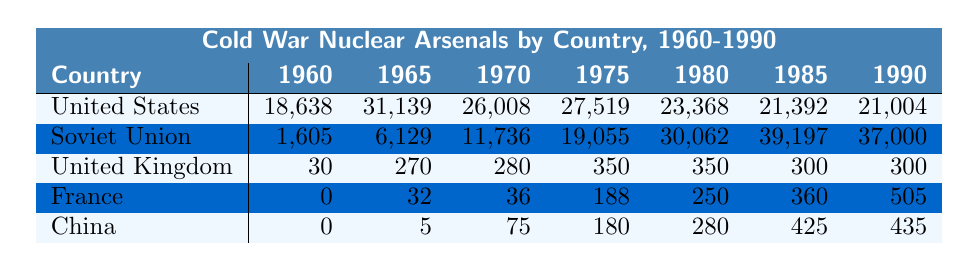What was the status of China's nuclear arsenal in 1960? According to the table, China had no nuclear weapons in 1960, as indicated by the value of 0.
Answer: 0 Which country had the highest number of nuclear warheads in 1985? In the year 1985, the Soviet Union had the highest number of nuclear warheads, totaling 39,197, as seen in the corresponding cell.
Answer: Soviet Union How many nuclear warheads did the United States have in 1975? The table indicates that the United States had 27,519 nuclear warheads in 1975, which is directly shown in the row for the United States under the year 1975.
Answer: 27,519 What was the percentage increase in the Soviet Union's nuclear arsenal from 1965 to 1970? To find the percentage increase, subtract the number of warheads in 1965 (6,129) from that in 1970 (11,736), yielding an increase of 5,607. The percentage increase is then (5,607 / 6,129) * 100, which equals approximately 91.5%.
Answer: 91.5% Did the United Kingdom's nuclear arsenal decrease from 1980 to 1990? In 1980, the United Kingdom had 350 nuclear warheads, while in 1990, it had 300. Since 300 is less than 350, this indicates a decrease.
Answer: Yes What was the combined total of nuclear warheads for the United States and the Soviet Union in 1990? To find the combined total, add the United States' nuclear warheads (21,004) to the Soviet Union's (37,000). This sums up to 58,004.
Answer: 58,004 Calculate the difference in nuclear arsenals between the United States and Soviet Union in 1980. The United States had 23,368 warheads, while the Soviet Union had 30,062 in 1980. The difference is calculated as 30,062 - 23,368, resulting in 6,694 more warheads for the Soviet Union.
Answer: 6,694 What trend can be observed in China’s nuclear arsenal from 1960 to 1990? The data shows that China started with 0 warheads in 1960 and gradually increased its arsenal to 435 by 1990, indicating consistent growth over the decades. This trend suggests a steady development in China's nuclear capabilities.
Answer: Consistent growth Was the United Kingdom's nuclear arsenal more than that of France in 1985? In 1985, the United Kingdom had 300 nuclear warheads while France had 360. Since 300 is less than 360, the United Kingdom did not have more than France in that year.
Answer: No What was the average number of nuclear warheads for the five countries in 1990? The totals for 1990 are 21,004 (USA), 37,000 (Soviet Union), 300 (UK), 505 (France), and 435 (China). Summing these gives 59,244. Dividing this by 5 gives the average of 11,848.8.
Answer: 11,848.8 